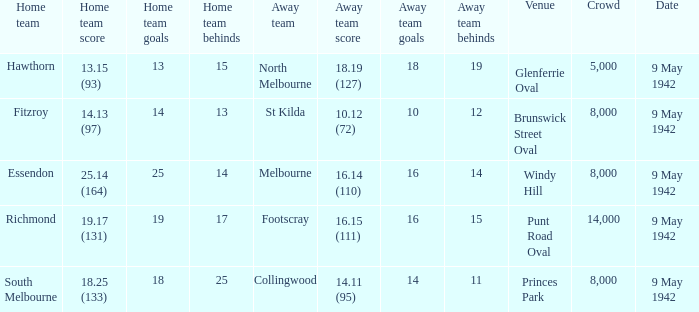How many people attended the game with the home team scoring 18.25 (133)? 1.0. 